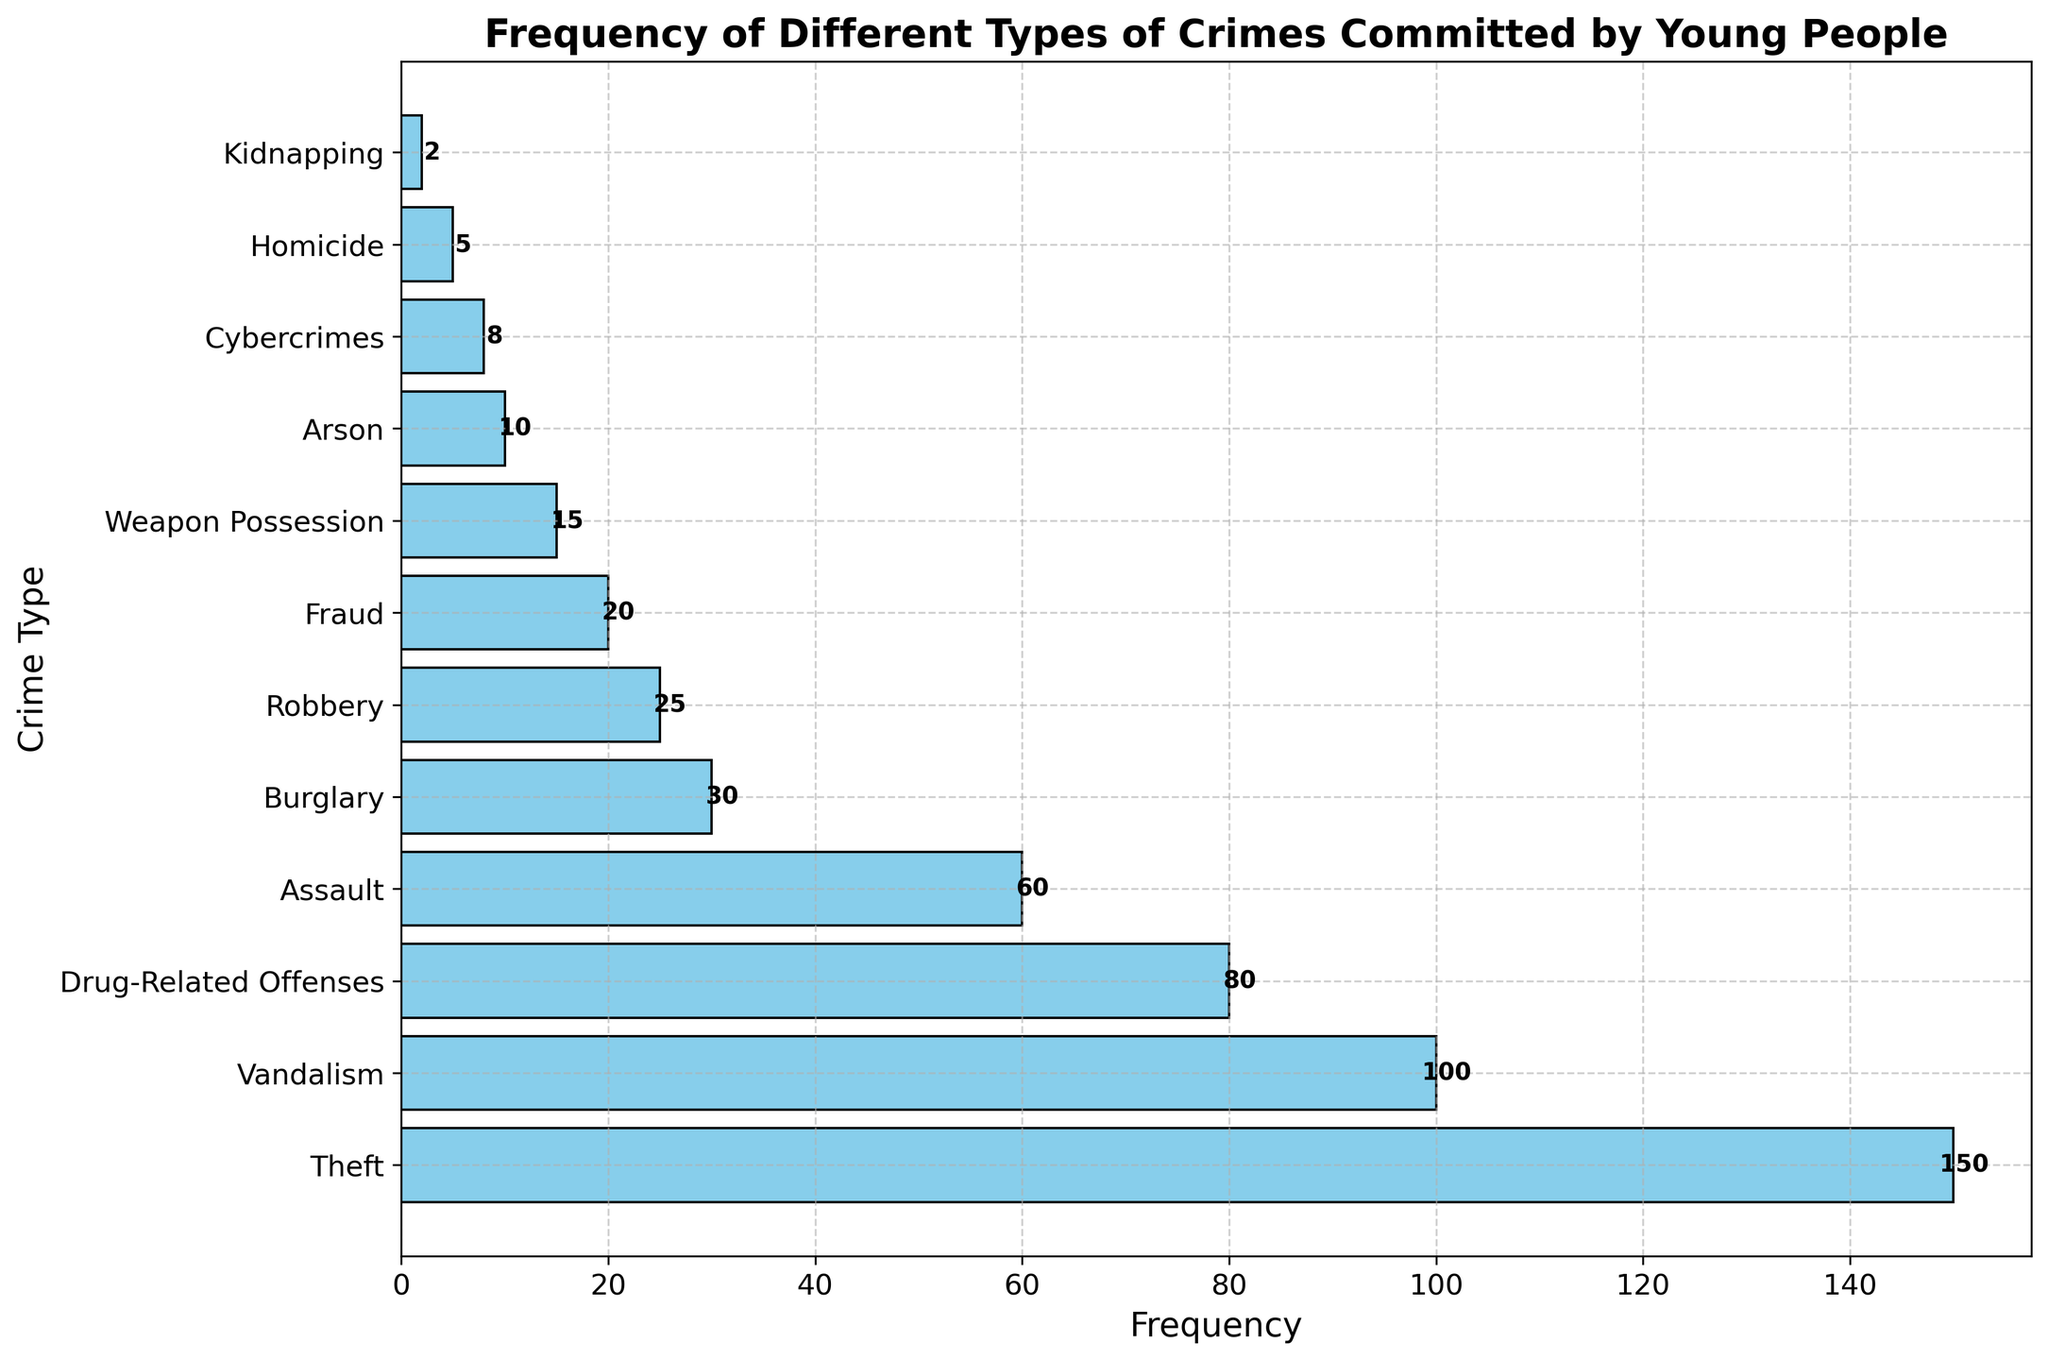Which crime type is committed the most frequently by young people? The histogram shows different crime types on the y-axis and their frequencies on the x-axis. The longest bar corresponds to 'Theft'.
Answer: Theft Which two crime types have the lowest frequency and what is their combined frequency? The two crime types with the smallest bars are 'Homicide' and 'Kidnapping', each with a frequency of 5 and 2, respectively. Their combined frequency is 5 + 2 = 7.
Answer: Homicide and Kidnapping, 7 How much more frequent is Theft compared to Assault? The bar for Theft corresponds to a frequency of 150 and the bar for Assault corresponds to a frequency of 60. The difference is 150 - 60 = 90.
Answer: 90 What is the average frequency of Cybercrimes, Arson, and Weapon Possession? The frequencies are 8 for Cybercrimes, 10 for Arson, and 15 for Weapon Possession. The sum is 8 + 10 + 15 = 33. The average is 33 / 3 = 11.
Answer: 11 What is the median frequency among all the listed crime types? After sorting the frequencies: [2, 5, 8, 10, 15, 20, 25, 30, 60, 80, 100, 150], the middle value for this ordered set of 12 values is the average of the 6th and 7th values. (20 + 25) / 2 = 22.5.
Answer: 22.5 Which crime type has a frequency exactly half that of Burglary? The frequency of Burglary is 30. Half of 30 is 15. The crime type with a frequency of 15 is 'Weapon Possession'.
Answer: Weapon Possession Is Vandalism more or less frequent than Drug-Related Offenses? The bar for Vandalism corresponds to a frequency of 100, and the bar for Drug-Related Offenses corresponds to 80. Thus, Vandalism is more frequent.
Answer: More frequent How many crime types have frequencies greater than 50? By looking at the histogram, the crime types with frequencies greater than 50 are 'Theft', 'Vandalism', 'Drug-Related Offenses', and 'Assault'. There are 4 such crime types.
Answer: 4 Which crime type shown has the most similar frequency to Cybercrimes? The frequency of Cybercrimes is 8. The crime type that has the most similar frequency is 'Arson' with a frequency of 10.
Answer: Arson 